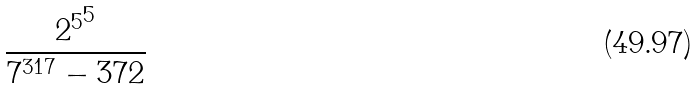Convert formula to latex. <formula><loc_0><loc_0><loc_500><loc_500>\frac { { 2 ^ { 5 } } ^ { 5 } } { 7 ^ { 3 1 7 } - 3 7 2 }</formula> 